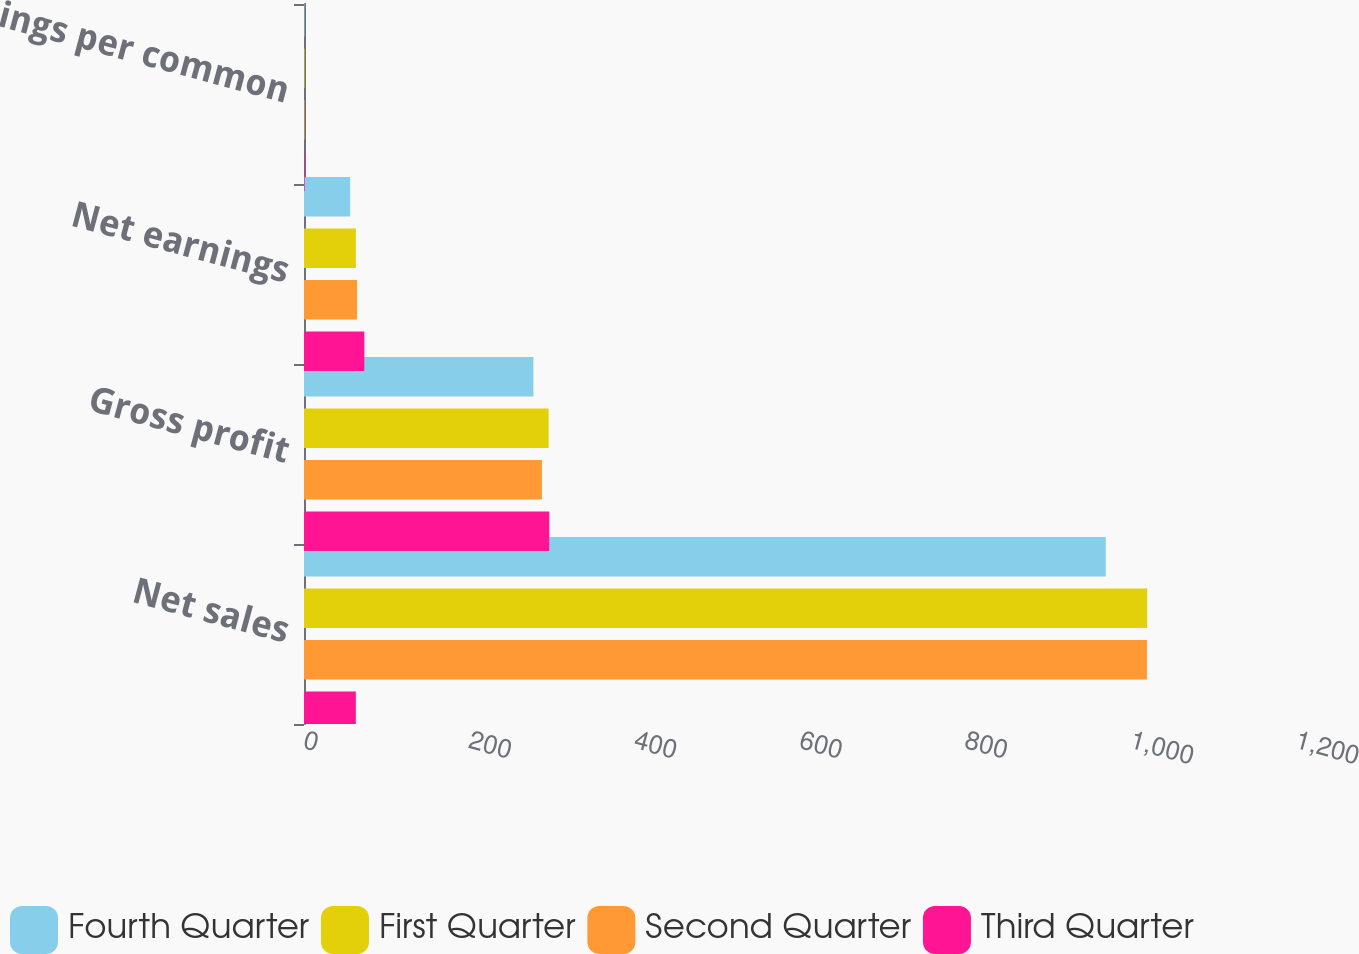Convert chart. <chart><loc_0><loc_0><loc_500><loc_500><stacked_bar_chart><ecel><fcel>Net sales<fcel>Gross profit<fcel>Net earnings<fcel>Earnings per common<nl><fcel>Fourth Quarter<fcel>969.8<fcel>277.5<fcel>55.8<fcel>0.58<nl><fcel>First Quarter<fcel>1020<fcel>295.9<fcel>62.7<fcel>0.66<nl><fcel>Second Quarter<fcel>1019.7<fcel>287.8<fcel>64.2<fcel>0.68<nl><fcel>Third Quarter<fcel>62.7<fcel>296.7<fcel>73<fcel>0.77<nl></chart> 